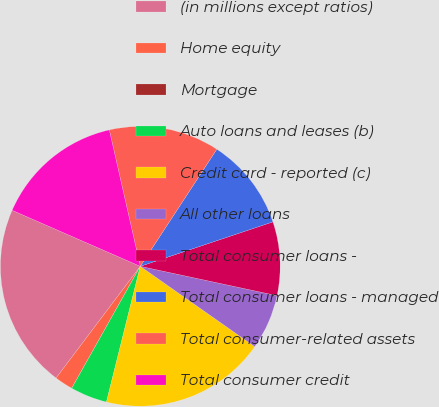Convert chart to OTSL. <chart><loc_0><loc_0><loc_500><loc_500><pie_chart><fcel>(in millions except ratios)<fcel>Home equity<fcel>Mortgage<fcel>Auto loans and leases (b)<fcel>Credit card - reported (c)<fcel>All other loans<fcel>Total consumer loans -<fcel>Total consumer loans - managed<fcel>Total consumer-related assets<fcel>Total consumer credit<nl><fcel>21.28%<fcel>2.13%<fcel>0.0%<fcel>4.26%<fcel>19.15%<fcel>6.38%<fcel>8.51%<fcel>10.64%<fcel>12.77%<fcel>14.89%<nl></chart> 